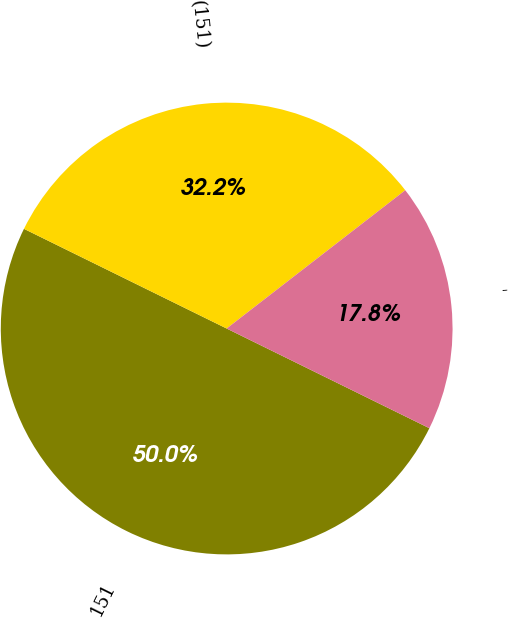Convert chart to OTSL. <chart><loc_0><loc_0><loc_500><loc_500><pie_chart><fcel>151<fcel>(151)<fcel>-<nl><fcel>50.0%<fcel>32.24%<fcel>17.76%<nl></chart> 